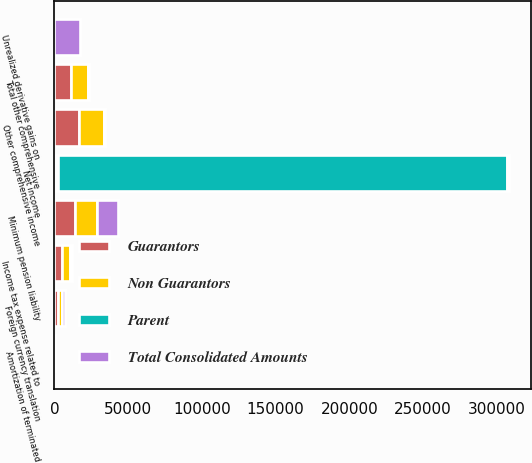<chart> <loc_0><loc_0><loc_500><loc_500><stacked_bar_chart><ecel><fcel>Net income<fcel>Unrealized derivative gains on<fcel>Amortization of terminated<fcel>Minimum pension liability<fcel>Foreign currency translation<fcel>Other comprehensive income<fcel>Income tax expense related to<fcel>Total other comprehensive<nl><fcel>Total Consolidated Amounts<fcel>1053<fcel>17668<fcel>336<fcel>14270<fcel>2431<fcel>631<fcel>1053<fcel>422<nl><fcel>Guarantors<fcel>1053<fcel>0<fcel>0<fcel>14270<fcel>2431<fcel>16701<fcel>5356<fcel>11345<nl><fcel>Parent<fcel>304995<fcel>0<fcel>0<fcel>0<fcel>0<fcel>0<fcel>0<fcel>0<nl><fcel>Non Guarantors<fcel>1053<fcel>0<fcel>0<fcel>14270<fcel>2431<fcel>16701<fcel>5356<fcel>11345<nl></chart> 